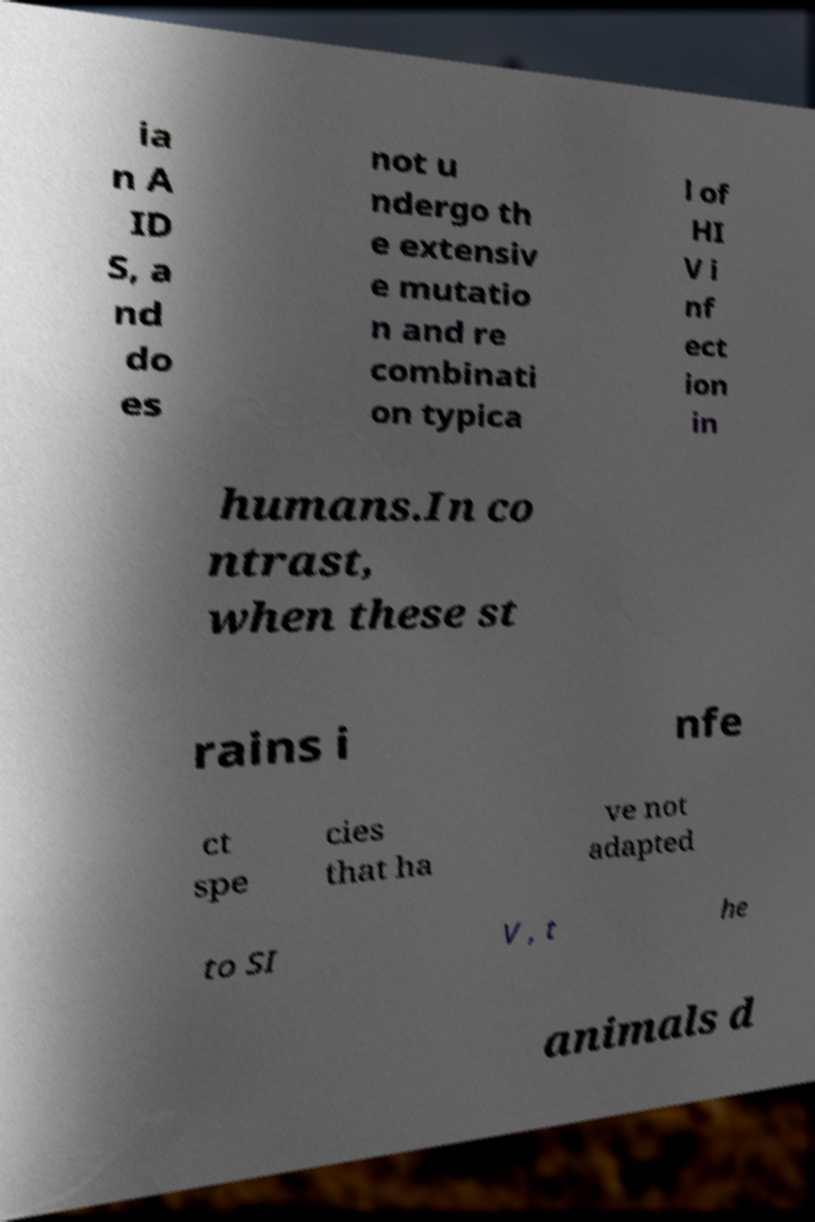There's text embedded in this image that I need extracted. Can you transcribe it verbatim? ia n A ID S, a nd do es not u ndergo th e extensiv e mutatio n and re combinati on typica l of HI V i nf ect ion in humans.In co ntrast, when these st rains i nfe ct spe cies that ha ve not adapted to SI V , t he animals d 